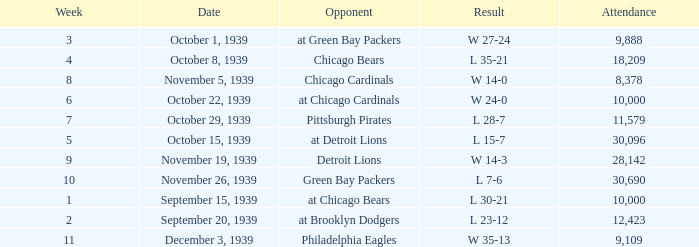Which Attendance has an Opponent of green bay packers, and a Week larger than 10? None. 